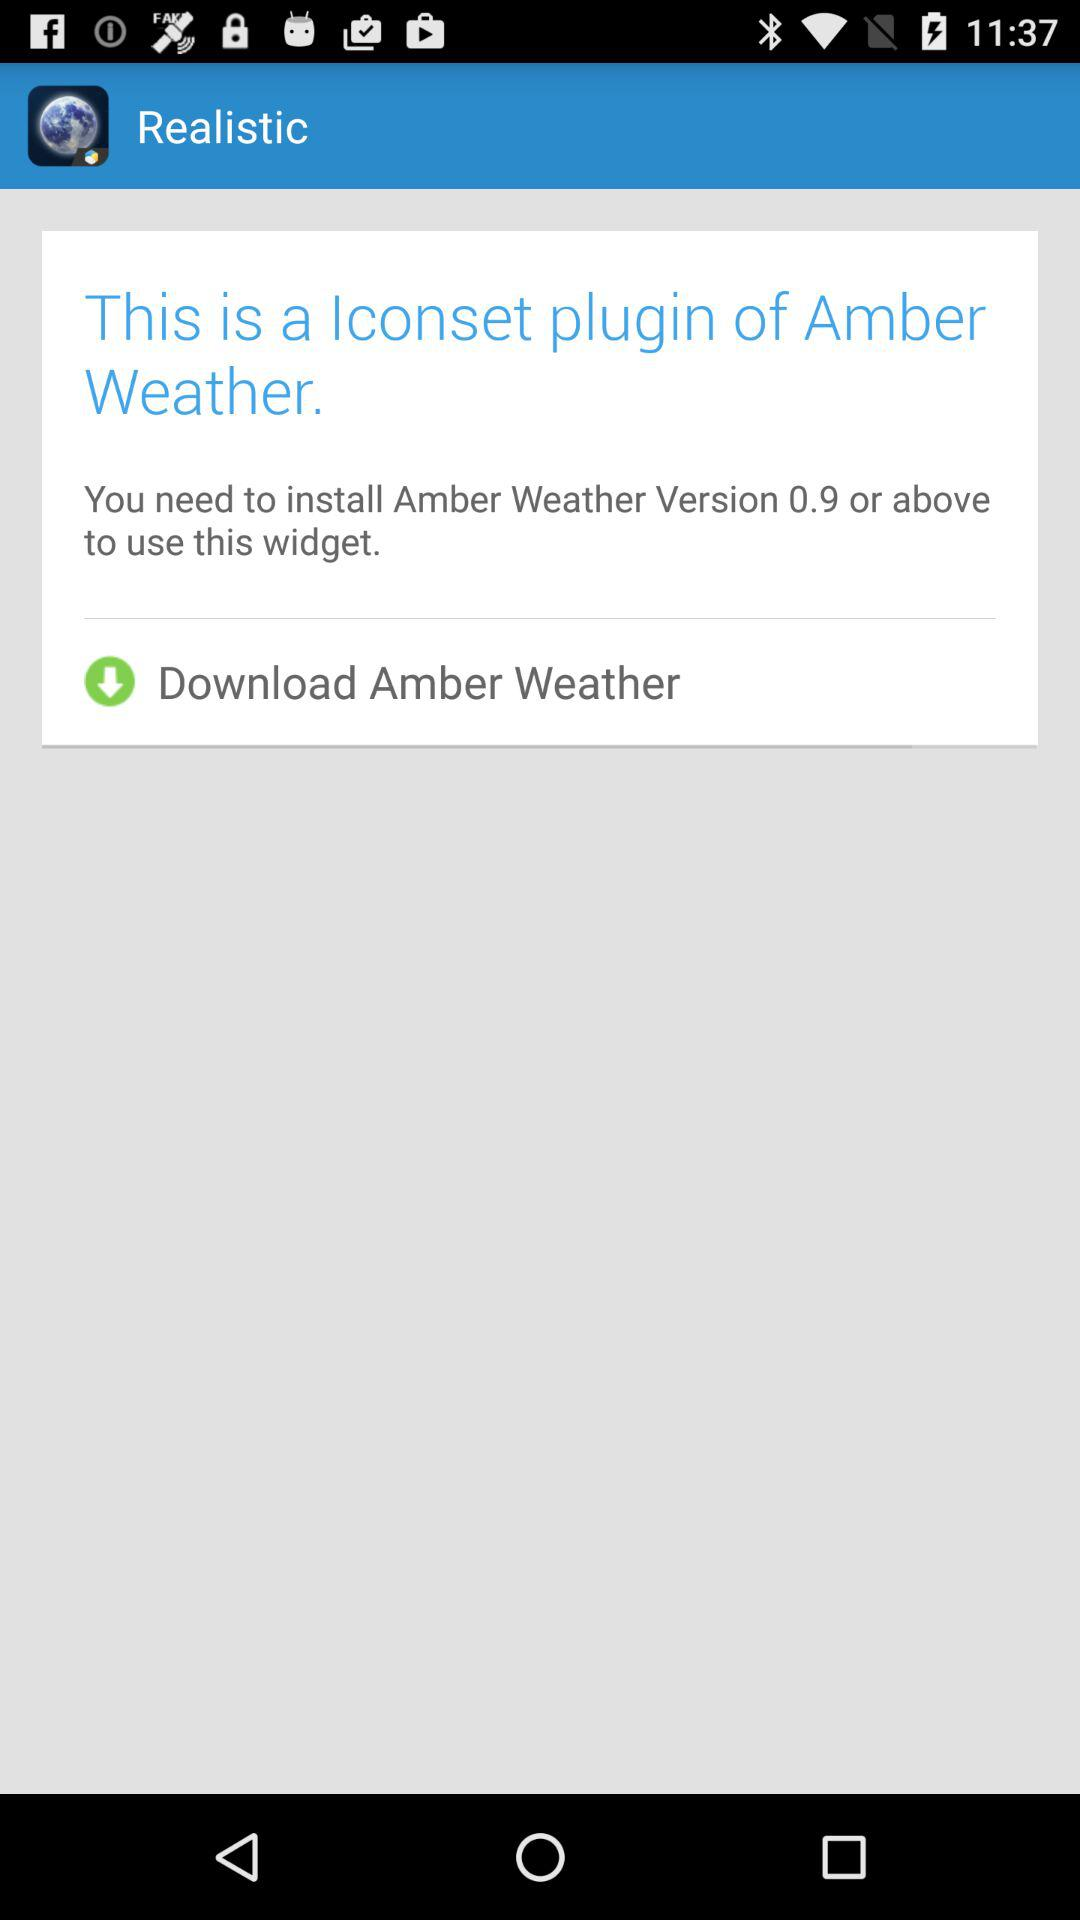What version do we need to install? You need to install version 0.9 or above. 